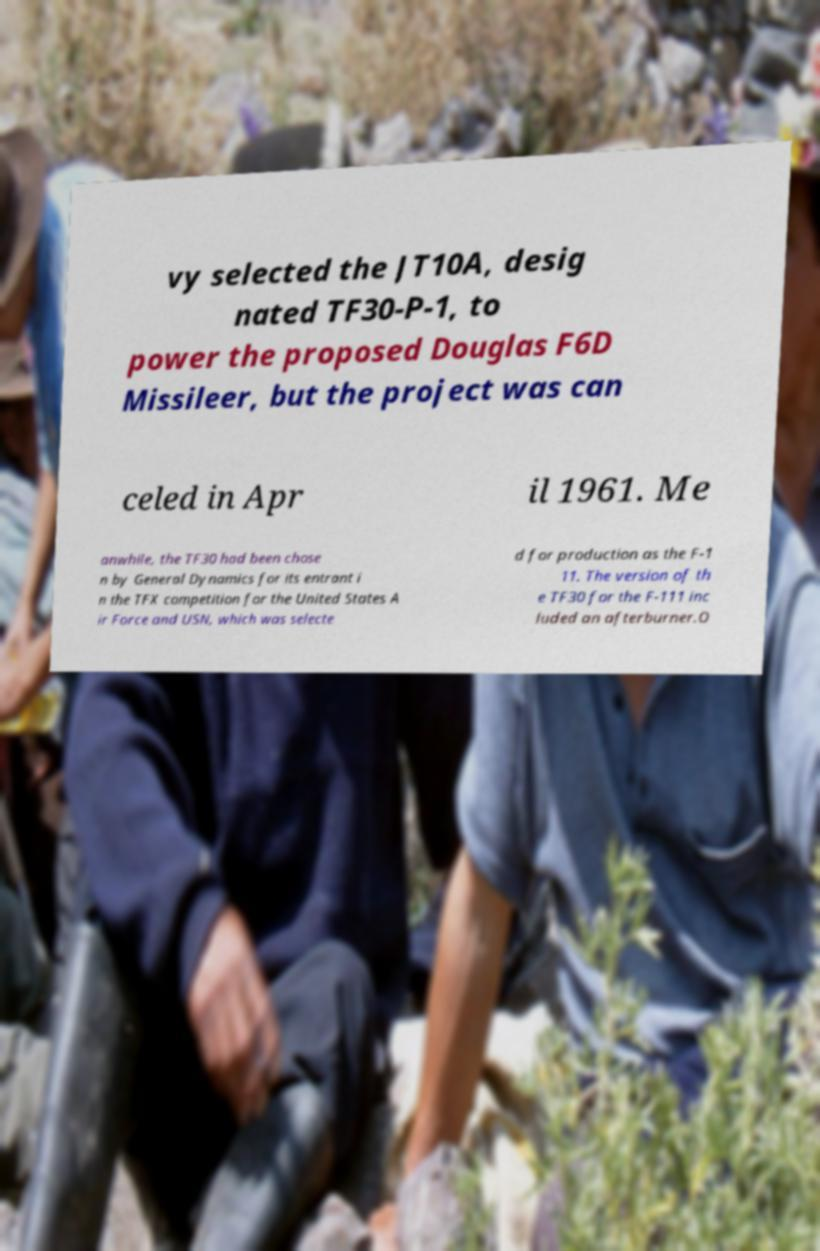There's text embedded in this image that I need extracted. Can you transcribe it verbatim? vy selected the JT10A, desig nated TF30-P-1, to power the proposed Douglas F6D Missileer, but the project was can celed in Apr il 1961. Me anwhile, the TF30 had been chose n by General Dynamics for its entrant i n the TFX competition for the United States A ir Force and USN, which was selecte d for production as the F-1 11. The version of th e TF30 for the F-111 inc luded an afterburner.O 